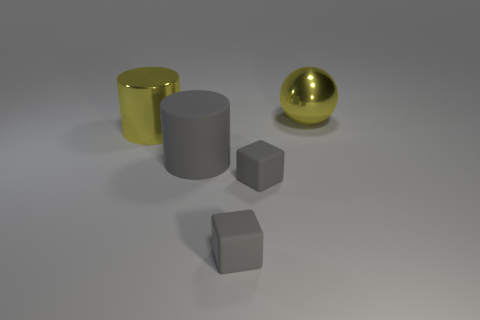Subtract all yellow cylinders. Subtract all blue cubes. How many cylinders are left? 1 Add 1 large shiny cylinders. How many objects exist? 6 Subtract all cylinders. How many objects are left? 3 Add 5 red spheres. How many red spheres exist? 5 Subtract 0 gray balls. How many objects are left? 5 Subtract all gray rubber things. Subtract all big gray rubber cylinders. How many objects are left? 1 Add 5 yellow shiny objects. How many yellow shiny objects are left? 7 